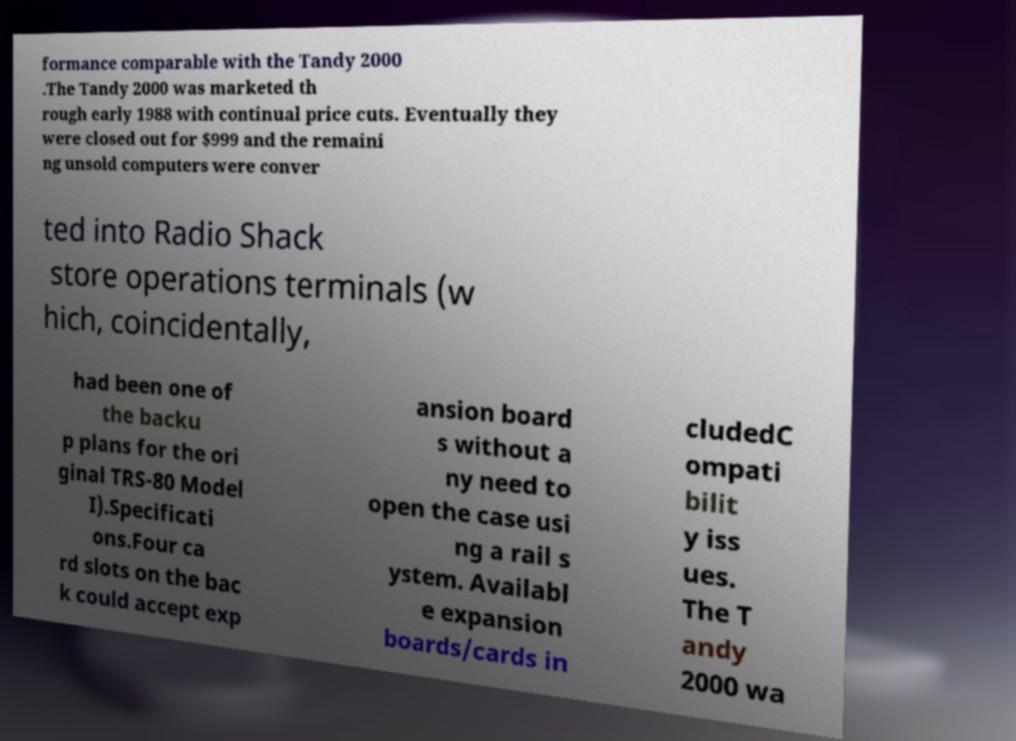Can you read and provide the text displayed in the image?This photo seems to have some interesting text. Can you extract and type it out for me? formance comparable with the Tandy 2000 .The Tandy 2000 was marketed th rough early 1988 with continual price cuts. Eventually they were closed out for $999 and the remaini ng unsold computers were conver ted into Radio Shack store operations terminals (w hich, coincidentally, had been one of the backu p plans for the ori ginal TRS-80 Model I).Specificati ons.Four ca rd slots on the bac k could accept exp ansion board s without a ny need to open the case usi ng a rail s ystem. Availabl e expansion boards/cards in cludedC ompati bilit y iss ues. The T andy 2000 wa 